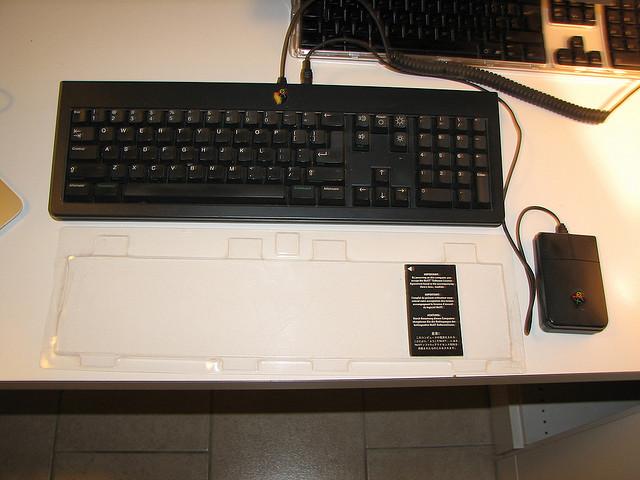Is there a mouse attached to the computer?
Answer briefly. Yes. Where is the mouse in relation to the keyboard?
Keep it brief. Right. What company is named?
Concise answer only. Dell. What color is the mouse?
Answer briefly. Black. Is this a cluttered area?
Be succinct. No. What's in front of the keyboard?
Be succinct. Keyboard cover. Is the keyboard plugged in?
Short answer required. Yes. 